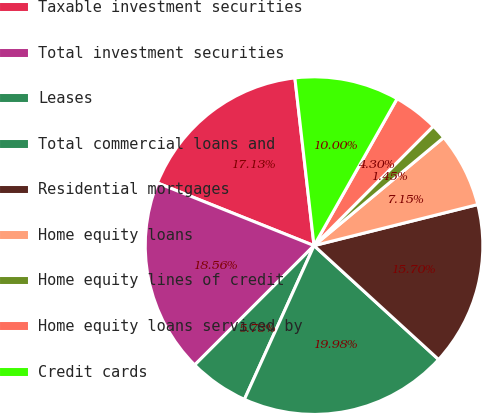Convert chart. <chart><loc_0><loc_0><loc_500><loc_500><pie_chart><fcel>Taxable investment securities<fcel>Total investment securities<fcel>Leases<fcel>Total commercial loans and<fcel>Residential mortgages<fcel>Home equity loans<fcel>Home equity lines of credit<fcel>Home equity loans serviced by<fcel>Credit cards<nl><fcel>17.13%<fcel>18.56%<fcel>5.73%<fcel>19.98%<fcel>15.7%<fcel>7.15%<fcel>1.45%<fcel>4.3%<fcel>10.0%<nl></chart> 